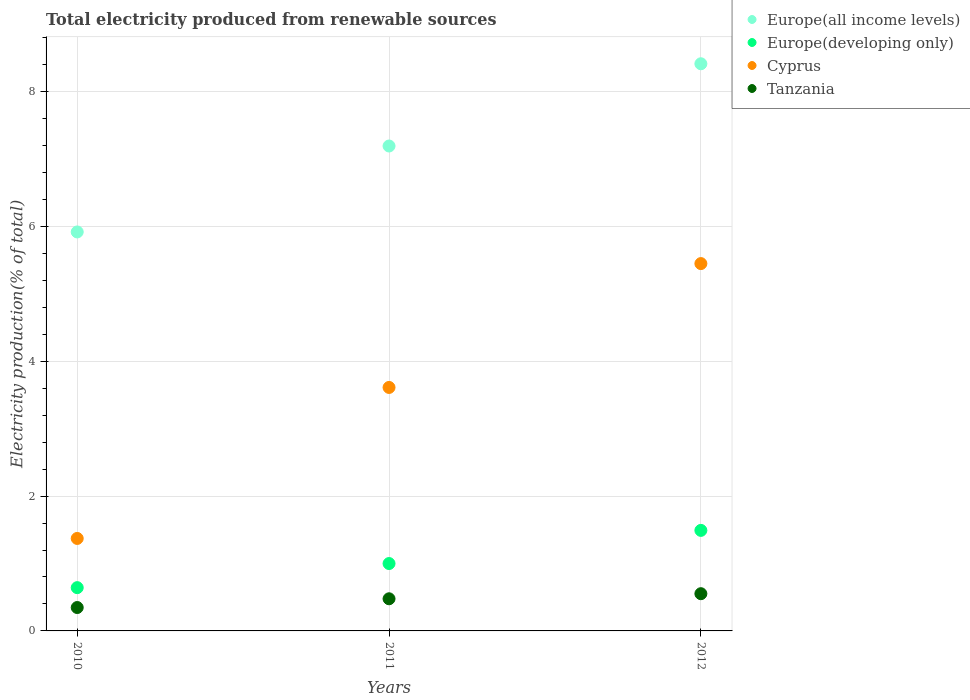How many different coloured dotlines are there?
Provide a succinct answer. 4. What is the total electricity produced in Tanzania in 2012?
Ensure brevity in your answer.  0.55. Across all years, what is the maximum total electricity produced in Europe(all income levels)?
Ensure brevity in your answer.  8.41. Across all years, what is the minimum total electricity produced in Europe(developing only)?
Give a very brief answer. 0.64. In which year was the total electricity produced in Europe(all income levels) maximum?
Offer a very short reply. 2012. In which year was the total electricity produced in Europe(all income levels) minimum?
Make the answer very short. 2010. What is the total total electricity produced in Tanzania in the graph?
Keep it short and to the point. 1.38. What is the difference between the total electricity produced in Europe(developing only) in 2010 and that in 2011?
Your answer should be very brief. -0.36. What is the difference between the total electricity produced in Europe(all income levels) in 2010 and the total electricity produced in Europe(developing only) in 2012?
Give a very brief answer. 4.43. What is the average total electricity produced in Europe(all income levels) per year?
Give a very brief answer. 7.17. In the year 2012, what is the difference between the total electricity produced in Europe(all income levels) and total electricity produced in Cyprus?
Ensure brevity in your answer.  2.96. In how many years, is the total electricity produced in Europe(developing only) greater than 3.2 %?
Offer a terse response. 0. What is the ratio of the total electricity produced in Europe(all income levels) in 2010 to that in 2012?
Keep it short and to the point. 0.7. Is the total electricity produced in Tanzania in 2010 less than that in 2011?
Your answer should be very brief. Yes. What is the difference between the highest and the second highest total electricity produced in Tanzania?
Your response must be concise. 0.08. What is the difference between the highest and the lowest total electricity produced in Tanzania?
Provide a succinct answer. 0.21. In how many years, is the total electricity produced in Europe(all income levels) greater than the average total electricity produced in Europe(all income levels) taken over all years?
Your answer should be very brief. 2. Is it the case that in every year, the sum of the total electricity produced in Europe(developing only) and total electricity produced in Europe(all income levels)  is greater than the sum of total electricity produced in Tanzania and total electricity produced in Cyprus?
Your answer should be compact. No. Is it the case that in every year, the sum of the total electricity produced in Tanzania and total electricity produced in Europe(developing only)  is greater than the total electricity produced in Europe(all income levels)?
Your response must be concise. No. Does the total electricity produced in Europe(all income levels) monotonically increase over the years?
Give a very brief answer. Yes. Is the total electricity produced in Cyprus strictly less than the total electricity produced in Europe(all income levels) over the years?
Offer a very short reply. Yes. Does the graph contain any zero values?
Your response must be concise. No. Does the graph contain grids?
Your answer should be very brief. Yes. How many legend labels are there?
Offer a terse response. 4. What is the title of the graph?
Offer a very short reply. Total electricity produced from renewable sources. What is the label or title of the X-axis?
Provide a short and direct response. Years. What is the Electricity production(% of total) in Europe(all income levels) in 2010?
Your answer should be compact. 5.92. What is the Electricity production(% of total) of Europe(developing only) in 2010?
Ensure brevity in your answer.  0.64. What is the Electricity production(% of total) of Cyprus in 2010?
Your answer should be compact. 1.37. What is the Electricity production(% of total) of Tanzania in 2010?
Your response must be concise. 0.35. What is the Electricity production(% of total) of Europe(all income levels) in 2011?
Provide a succinct answer. 7.19. What is the Electricity production(% of total) of Europe(developing only) in 2011?
Make the answer very short. 1. What is the Electricity production(% of total) of Cyprus in 2011?
Your response must be concise. 3.61. What is the Electricity production(% of total) in Tanzania in 2011?
Provide a short and direct response. 0.48. What is the Electricity production(% of total) in Europe(all income levels) in 2012?
Offer a terse response. 8.41. What is the Electricity production(% of total) in Europe(developing only) in 2012?
Make the answer very short. 1.49. What is the Electricity production(% of total) in Cyprus in 2012?
Your response must be concise. 5.45. What is the Electricity production(% of total) of Tanzania in 2012?
Give a very brief answer. 0.55. Across all years, what is the maximum Electricity production(% of total) of Europe(all income levels)?
Your answer should be compact. 8.41. Across all years, what is the maximum Electricity production(% of total) of Europe(developing only)?
Make the answer very short. 1.49. Across all years, what is the maximum Electricity production(% of total) of Cyprus?
Your answer should be compact. 5.45. Across all years, what is the maximum Electricity production(% of total) of Tanzania?
Provide a succinct answer. 0.55. Across all years, what is the minimum Electricity production(% of total) of Europe(all income levels)?
Ensure brevity in your answer.  5.92. Across all years, what is the minimum Electricity production(% of total) in Europe(developing only)?
Keep it short and to the point. 0.64. Across all years, what is the minimum Electricity production(% of total) in Cyprus?
Make the answer very short. 1.37. Across all years, what is the minimum Electricity production(% of total) in Tanzania?
Provide a succinct answer. 0.35. What is the total Electricity production(% of total) in Europe(all income levels) in the graph?
Keep it short and to the point. 21.52. What is the total Electricity production(% of total) in Europe(developing only) in the graph?
Offer a terse response. 3.13. What is the total Electricity production(% of total) of Cyprus in the graph?
Keep it short and to the point. 10.43. What is the total Electricity production(% of total) in Tanzania in the graph?
Your answer should be compact. 1.38. What is the difference between the Electricity production(% of total) of Europe(all income levels) in 2010 and that in 2011?
Ensure brevity in your answer.  -1.27. What is the difference between the Electricity production(% of total) in Europe(developing only) in 2010 and that in 2011?
Give a very brief answer. -0.36. What is the difference between the Electricity production(% of total) of Cyprus in 2010 and that in 2011?
Your response must be concise. -2.24. What is the difference between the Electricity production(% of total) in Tanzania in 2010 and that in 2011?
Your answer should be very brief. -0.13. What is the difference between the Electricity production(% of total) in Europe(all income levels) in 2010 and that in 2012?
Offer a very short reply. -2.49. What is the difference between the Electricity production(% of total) of Europe(developing only) in 2010 and that in 2012?
Make the answer very short. -0.85. What is the difference between the Electricity production(% of total) in Cyprus in 2010 and that in 2012?
Provide a short and direct response. -4.08. What is the difference between the Electricity production(% of total) in Tanzania in 2010 and that in 2012?
Give a very brief answer. -0.21. What is the difference between the Electricity production(% of total) in Europe(all income levels) in 2011 and that in 2012?
Provide a succinct answer. -1.22. What is the difference between the Electricity production(% of total) of Europe(developing only) in 2011 and that in 2012?
Ensure brevity in your answer.  -0.49. What is the difference between the Electricity production(% of total) of Cyprus in 2011 and that in 2012?
Provide a succinct answer. -1.84. What is the difference between the Electricity production(% of total) of Tanzania in 2011 and that in 2012?
Make the answer very short. -0.08. What is the difference between the Electricity production(% of total) in Europe(all income levels) in 2010 and the Electricity production(% of total) in Europe(developing only) in 2011?
Ensure brevity in your answer.  4.92. What is the difference between the Electricity production(% of total) of Europe(all income levels) in 2010 and the Electricity production(% of total) of Cyprus in 2011?
Offer a very short reply. 2.31. What is the difference between the Electricity production(% of total) of Europe(all income levels) in 2010 and the Electricity production(% of total) of Tanzania in 2011?
Make the answer very short. 5.44. What is the difference between the Electricity production(% of total) of Europe(developing only) in 2010 and the Electricity production(% of total) of Cyprus in 2011?
Provide a succinct answer. -2.97. What is the difference between the Electricity production(% of total) in Europe(developing only) in 2010 and the Electricity production(% of total) in Tanzania in 2011?
Provide a short and direct response. 0.17. What is the difference between the Electricity production(% of total) in Cyprus in 2010 and the Electricity production(% of total) in Tanzania in 2011?
Ensure brevity in your answer.  0.89. What is the difference between the Electricity production(% of total) in Europe(all income levels) in 2010 and the Electricity production(% of total) in Europe(developing only) in 2012?
Provide a succinct answer. 4.43. What is the difference between the Electricity production(% of total) of Europe(all income levels) in 2010 and the Electricity production(% of total) of Cyprus in 2012?
Ensure brevity in your answer.  0.47. What is the difference between the Electricity production(% of total) in Europe(all income levels) in 2010 and the Electricity production(% of total) in Tanzania in 2012?
Give a very brief answer. 5.37. What is the difference between the Electricity production(% of total) of Europe(developing only) in 2010 and the Electricity production(% of total) of Cyprus in 2012?
Offer a very short reply. -4.81. What is the difference between the Electricity production(% of total) in Europe(developing only) in 2010 and the Electricity production(% of total) in Tanzania in 2012?
Offer a terse response. 0.09. What is the difference between the Electricity production(% of total) in Cyprus in 2010 and the Electricity production(% of total) in Tanzania in 2012?
Keep it short and to the point. 0.82. What is the difference between the Electricity production(% of total) in Europe(all income levels) in 2011 and the Electricity production(% of total) in Europe(developing only) in 2012?
Your answer should be very brief. 5.7. What is the difference between the Electricity production(% of total) of Europe(all income levels) in 2011 and the Electricity production(% of total) of Cyprus in 2012?
Provide a succinct answer. 1.74. What is the difference between the Electricity production(% of total) in Europe(all income levels) in 2011 and the Electricity production(% of total) in Tanzania in 2012?
Your response must be concise. 6.64. What is the difference between the Electricity production(% of total) in Europe(developing only) in 2011 and the Electricity production(% of total) in Cyprus in 2012?
Give a very brief answer. -4.45. What is the difference between the Electricity production(% of total) of Europe(developing only) in 2011 and the Electricity production(% of total) of Tanzania in 2012?
Offer a terse response. 0.45. What is the difference between the Electricity production(% of total) in Cyprus in 2011 and the Electricity production(% of total) in Tanzania in 2012?
Ensure brevity in your answer.  3.06. What is the average Electricity production(% of total) in Europe(all income levels) per year?
Make the answer very short. 7.17. What is the average Electricity production(% of total) in Europe(developing only) per year?
Offer a terse response. 1.04. What is the average Electricity production(% of total) of Cyprus per year?
Keep it short and to the point. 3.48. What is the average Electricity production(% of total) of Tanzania per year?
Offer a very short reply. 0.46. In the year 2010, what is the difference between the Electricity production(% of total) of Europe(all income levels) and Electricity production(% of total) of Europe(developing only)?
Keep it short and to the point. 5.28. In the year 2010, what is the difference between the Electricity production(% of total) in Europe(all income levels) and Electricity production(% of total) in Cyprus?
Provide a succinct answer. 4.55. In the year 2010, what is the difference between the Electricity production(% of total) in Europe(all income levels) and Electricity production(% of total) in Tanzania?
Keep it short and to the point. 5.57. In the year 2010, what is the difference between the Electricity production(% of total) in Europe(developing only) and Electricity production(% of total) in Cyprus?
Make the answer very short. -0.73. In the year 2010, what is the difference between the Electricity production(% of total) of Europe(developing only) and Electricity production(% of total) of Tanzania?
Your answer should be very brief. 0.29. In the year 2010, what is the difference between the Electricity production(% of total) in Cyprus and Electricity production(% of total) in Tanzania?
Offer a terse response. 1.02. In the year 2011, what is the difference between the Electricity production(% of total) in Europe(all income levels) and Electricity production(% of total) in Europe(developing only)?
Your response must be concise. 6.19. In the year 2011, what is the difference between the Electricity production(% of total) in Europe(all income levels) and Electricity production(% of total) in Cyprus?
Your answer should be compact. 3.58. In the year 2011, what is the difference between the Electricity production(% of total) of Europe(all income levels) and Electricity production(% of total) of Tanzania?
Offer a very short reply. 6.72. In the year 2011, what is the difference between the Electricity production(% of total) in Europe(developing only) and Electricity production(% of total) in Cyprus?
Provide a succinct answer. -2.61. In the year 2011, what is the difference between the Electricity production(% of total) of Europe(developing only) and Electricity production(% of total) of Tanzania?
Your answer should be very brief. 0.52. In the year 2011, what is the difference between the Electricity production(% of total) in Cyprus and Electricity production(% of total) in Tanzania?
Ensure brevity in your answer.  3.13. In the year 2012, what is the difference between the Electricity production(% of total) in Europe(all income levels) and Electricity production(% of total) in Europe(developing only)?
Your answer should be very brief. 6.92. In the year 2012, what is the difference between the Electricity production(% of total) in Europe(all income levels) and Electricity production(% of total) in Cyprus?
Offer a terse response. 2.96. In the year 2012, what is the difference between the Electricity production(% of total) in Europe(all income levels) and Electricity production(% of total) in Tanzania?
Your response must be concise. 7.86. In the year 2012, what is the difference between the Electricity production(% of total) of Europe(developing only) and Electricity production(% of total) of Cyprus?
Ensure brevity in your answer.  -3.96. In the year 2012, what is the difference between the Electricity production(% of total) of Europe(developing only) and Electricity production(% of total) of Tanzania?
Give a very brief answer. 0.94. In the year 2012, what is the difference between the Electricity production(% of total) in Cyprus and Electricity production(% of total) in Tanzania?
Make the answer very short. 4.9. What is the ratio of the Electricity production(% of total) of Europe(all income levels) in 2010 to that in 2011?
Give a very brief answer. 0.82. What is the ratio of the Electricity production(% of total) in Europe(developing only) in 2010 to that in 2011?
Offer a very short reply. 0.64. What is the ratio of the Electricity production(% of total) in Cyprus in 2010 to that in 2011?
Offer a terse response. 0.38. What is the ratio of the Electricity production(% of total) in Tanzania in 2010 to that in 2011?
Your answer should be very brief. 0.73. What is the ratio of the Electricity production(% of total) of Europe(all income levels) in 2010 to that in 2012?
Provide a short and direct response. 0.7. What is the ratio of the Electricity production(% of total) in Europe(developing only) in 2010 to that in 2012?
Offer a very short reply. 0.43. What is the ratio of the Electricity production(% of total) in Cyprus in 2010 to that in 2012?
Your answer should be compact. 0.25. What is the ratio of the Electricity production(% of total) of Tanzania in 2010 to that in 2012?
Offer a terse response. 0.63. What is the ratio of the Electricity production(% of total) in Europe(all income levels) in 2011 to that in 2012?
Your answer should be compact. 0.85. What is the ratio of the Electricity production(% of total) of Europe(developing only) in 2011 to that in 2012?
Provide a succinct answer. 0.67. What is the ratio of the Electricity production(% of total) in Cyprus in 2011 to that in 2012?
Make the answer very short. 0.66. What is the ratio of the Electricity production(% of total) of Tanzania in 2011 to that in 2012?
Offer a very short reply. 0.86. What is the difference between the highest and the second highest Electricity production(% of total) of Europe(all income levels)?
Your answer should be compact. 1.22. What is the difference between the highest and the second highest Electricity production(% of total) of Europe(developing only)?
Offer a very short reply. 0.49. What is the difference between the highest and the second highest Electricity production(% of total) of Cyprus?
Provide a succinct answer. 1.84. What is the difference between the highest and the second highest Electricity production(% of total) in Tanzania?
Offer a terse response. 0.08. What is the difference between the highest and the lowest Electricity production(% of total) of Europe(all income levels)?
Your answer should be compact. 2.49. What is the difference between the highest and the lowest Electricity production(% of total) in Europe(developing only)?
Make the answer very short. 0.85. What is the difference between the highest and the lowest Electricity production(% of total) of Cyprus?
Your answer should be very brief. 4.08. What is the difference between the highest and the lowest Electricity production(% of total) of Tanzania?
Provide a succinct answer. 0.21. 